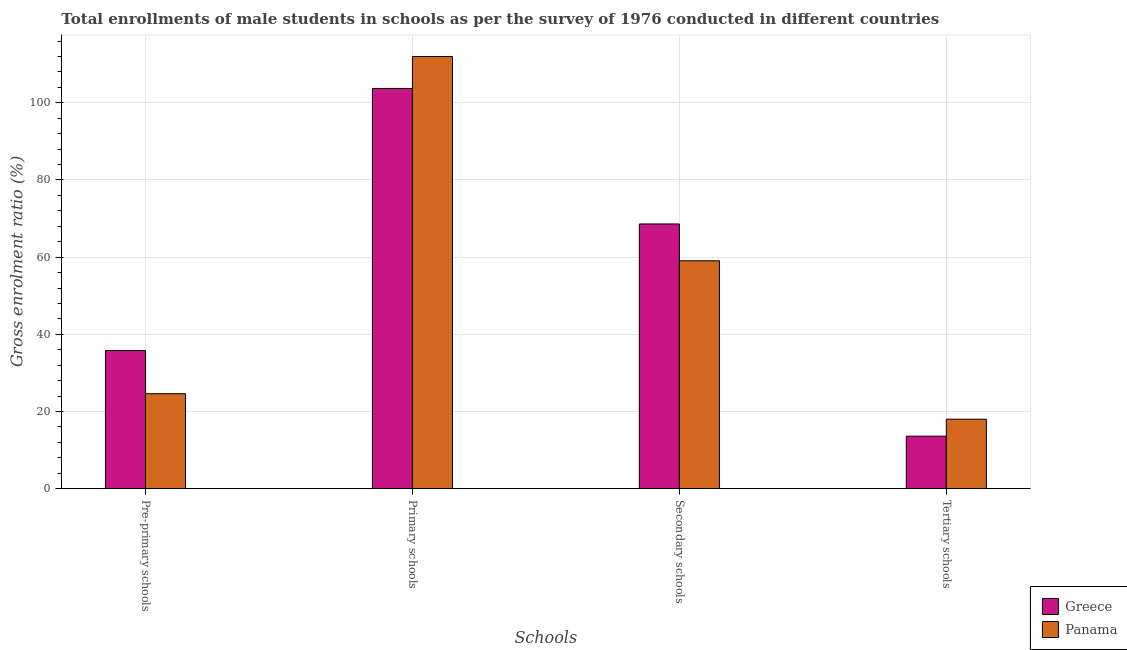Are the number of bars per tick equal to the number of legend labels?
Provide a short and direct response. Yes. How many bars are there on the 4th tick from the left?
Make the answer very short. 2. How many bars are there on the 1st tick from the right?
Your response must be concise. 2. What is the label of the 3rd group of bars from the left?
Ensure brevity in your answer.  Secondary schools. What is the gross enrolment ratio(male) in tertiary schools in Greece?
Give a very brief answer. 13.6. Across all countries, what is the maximum gross enrolment ratio(male) in primary schools?
Your answer should be compact. 112. Across all countries, what is the minimum gross enrolment ratio(male) in pre-primary schools?
Provide a succinct answer. 24.62. In which country was the gross enrolment ratio(male) in pre-primary schools maximum?
Ensure brevity in your answer.  Greece. In which country was the gross enrolment ratio(male) in pre-primary schools minimum?
Your response must be concise. Panama. What is the total gross enrolment ratio(male) in primary schools in the graph?
Ensure brevity in your answer.  215.71. What is the difference between the gross enrolment ratio(male) in pre-primary schools in Panama and that in Greece?
Keep it short and to the point. -11.18. What is the difference between the gross enrolment ratio(male) in tertiary schools in Greece and the gross enrolment ratio(male) in secondary schools in Panama?
Your answer should be compact. -45.45. What is the average gross enrolment ratio(male) in secondary schools per country?
Provide a succinct answer. 63.82. What is the difference between the gross enrolment ratio(male) in tertiary schools and gross enrolment ratio(male) in primary schools in Greece?
Provide a short and direct response. -90.11. What is the ratio of the gross enrolment ratio(male) in secondary schools in Greece to that in Panama?
Your response must be concise. 1.16. Is the difference between the gross enrolment ratio(male) in tertiary schools in Greece and Panama greater than the difference between the gross enrolment ratio(male) in secondary schools in Greece and Panama?
Keep it short and to the point. No. What is the difference between the highest and the second highest gross enrolment ratio(male) in secondary schools?
Your answer should be compact. 9.55. What is the difference between the highest and the lowest gross enrolment ratio(male) in pre-primary schools?
Your response must be concise. 11.18. In how many countries, is the gross enrolment ratio(male) in secondary schools greater than the average gross enrolment ratio(male) in secondary schools taken over all countries?
Ensure brevity in your answer.  1. Is the sum of the gross enrolment ratio(male) in pre-primary schools in Greece and Panama greater than the maximum gross enrolment ratio(male) in tertiary schools across all countries?
Your response must be concise. Yes. Is it the case that in every country, the sum of the gross enrolment ratio(male) in pre-primary schools and gross enrolment ratio(male) in tertiary schools is greater than the sum of gross enrolment ratio(male) in primary schools and gross enrolment ratio(male) in secondary schools?
Your answer should be very brief. No. What does the 2nd bar from the left in Primary schools represents?
Give a very brief answer. Panama. What does the 2nd bar from the right in Primary schools represents?
Keep it short and to the point. Greece. Is it the case that in every country, the sum of the gross enrolment ratio(male) in pre-primary schools and gross enrolment ratio(male) in primary schools is greater than the gross enrolment ratio(male) in secondary schools?
Make the answer very short. Yes. Are all the bars in the graph horizontal?
Keep it short and to the point. No. How many countries are there in the graph?
Make the answer very short. 2. What is the difference between two consecutive major ticks on the Y-axis?
Keep it short and to the point. 20. Are the values on the major ticks of Y-axis written in scientific E-notation?
Make the answer very short. No. Does the graph contain any zero values?
Offer a terse response. No. Where does the legend appear in the graph?
Ensure brevity in your answer.  Bottom right. What is the title of the graph?
Provide a short and direct response. Total enrollments of male students in schools as per the survey of 1976 conducted in different countries. Does "Tajikistan" appear as one of the legend labels in the graph?
Your answer should be very brief. No. What is the label or title of the X-axis?
Your answer should be very brief. Schools. What is the Gross enrolment ratio (%) of Greece in Pre-primary schools?
Provide a short and direct response. 35.79. What is the Gross enrolment ratio (%) in Panama in Pre-primary schools?
Offer a terse response. 24.62. What is the Gross enrolment ratio (%) of Greece in Primary schools?
Your answer should be very brief. 103.71. What is the Gross enrolment ratio (%) of Panama in Primary schools?
Your answer should be very brief. 112. What is the Gross enrolment ratio (%) of Greece in Secondary schools?
Offer a very short reply. 68.6. What is the Gross enrolment ratio (%) in Panama in Secondary schools?
Give a very brief answer. 59.05. What is the Gross enrolment ratio (%) in Greece in Tertiary schools?
Provide a short and direct response. 13.6. What is the Gross enrolment ratio (%) in Panama in Tertiary schools?
Keep it short and to the point. 18.01. Across all Schools, what is the maximum Gross enrolment ratio (%) of Greece?
Offer a terse response. 103.71. Across all Schools, what is the maximum Gross enrolment ratio (%) of Panama?
Provide a succinct answer. 112. Across all Schools, what is the minimum Gross enrolment ratio (%) of Greece?
Offer a terse response. 13.6. Across all Schools, what is the minimum Gross enrolment ratio (%) of Panama?
Your answer should be very brief. 18.01. What is the total Gross enrolment ratio (%) of Greece in the graph?
Your answer should be very brief. 221.7. What is the total Gross enrolment ratio (%) in Panama in the graph?
Provide a short and direct response. 213.67. What is the difference between the Gross enrolment ratio (%) of Greece in Pre-primary schools and that in Primary schools?
Ensure brevity in your answer.  -67.92. What is the difference between the Gross enrolment ratio (%) of Panama in Pre-primary schools and that in Primary schools?
Keep it short and to the point. -87.38. What is the difference between the Gross enrolment ratio (%) in Greece in Pre-primary schools and that in Secondary schools?
Your answer should be very brief. -32.81. What is the difference between the Gross enrolment ratio (%) of Panama in Pre-primary schools and that in Secondary schools?
Ensure brevity in your answer.  -34.44. What is the difference between the Gross enrolment ratio (%) of Greece in Pre-primary schools and that in Tertiary schools?
Make the answer very short. 22.19. What is the difference between the Gross enrolment ratio (%) in Panama in Pre-primary schools and that in Tertiary schools?
Offer a very short reply. 6.61. What is the difference between the Gross enrolment ratio (%) in Greece in Primary schools and that in Secondary schools?
Give a very brief answer. 35.12. What is the difference between the Gross enrolment ratio (%) of Panama in Primary schools and that in Secondary schools?
Ensure brevity in your answer.  52.95. What is the difference between the Gross enrolment ratio (%) of Greece in Primary schools and that in Tertiary schools?
Ensure brevity in your answer.  90.11. What is the difference between the Gross enrolment ratio (%) of Panama in Primary schools and that in Tertiary schools?
Provide a short and direct response. 93.99. What is the difference between the Gross enrolment ratio (%) in Greece in Secondary schools and that in Tertiary schools?
Give a very brief answer. 55. What is the difference between the Gross enrolment ratio (%) in Panama in Secondary schools and that in Tertiary schools?
Ensure brevity in your answer.  41.04. What is the difference between the Gross enrolment ratio (%) in Greece in Pre-primary schools and the Gross enrolment ratio (%) in Panama in Primary schools?
Offer a terse response. -76.21. What is the difference between the Gross enrolment ratio (%) of Greece in Pre-primary schools and the Gross enrolment ratio (%) of Panama in Secondary schools?
Make the answer very short. -23.26. What is the difference between the Gross enrolment ratio (%) in Greece in Pre-primary schools and the Gross enrolment ratio (%) in Panama in Tertiary schools?
Give a very brief answer. 17.78. What is the difference between the Gross enrolment ratio (%) in Greece in Primary schools and the Gross enrolment ratio (%) in Panama in Secondary schools?
Your answer should be very brief. 44.66. What is the difference between the Gross enrolment ratio (%) of Greece in Primary schools and the Gross enrolment ratio (%) of Panama in Tertiary schools?
Offer a terse response. 85.7. What is the difference between the Gross enrolment ratio (%) of Greece in Secondary schools and the Gross enrolment ratio (%) of Panama in Tertiary schools?
Your answer should be very brief. 50.59. What is the average Gross enrolment ratio (%) of Greece per Schools?
Keep it short and to the point. 55.43. What is the average Gross enrolment ratio (%) of Panama per Schools?
Offer a terse response. 53.42. What is the difference between the Gross enrolment ratio (%) in Greece and Gross enrolment ratio (%) in Panama in Pre-primary schools?
Keep it short and to the point. 11.18. What is the difference between the Gross enrolment ratio (%) of Greece and Gross enrolment ratio (%) of Panama in Primary schools?
Offer a terse response. -8.29. What is the difference between the Gross enrolment ratio (%) in Greece and Gross enrolment ratio (%) in Panama in Secondary schools?
Ensure brevity in your answer.  9.55. What is the difference between the Gross enrolment ratio (%) of Greece and Gross enrolment ratio (%) of Panama in Tertiary schools?
Provide a short and direct response. -4.41. What is the ratio of the Gross enrolment ratio (%) in Greece in Pre-primary schools to that in Primary schools?
Offer a terse response. 0.35. What is the ratio of the Gross enrolment ratio (%) in Panama in Pre-primary schools to that in Primary schools?
Provide a short and direct response. 0.22. What is the ratio of the Gross enrolment ratio (%) in Greece in Pre-primary schools to that in Secondary schools?
Provide a succinct answer. 0.52. What is the ratio of the Gross enrolment ratio (%) of Panama in Pre-primary schools to that in Secondary schools?
Keep it short and to the point. 0.42. What is the ratio of the Gross enrolment ratio (%) of Greece in Pre-primary schools to that in Tertiary schools?
Offer a very short reply. 2.63. What is the ratio of the Gross enrolment ratio (%) of Panama in Pre-primary schools to that in Tertiary schools?
Your response must be concise. 1.37. What is the ratio of the Gross enrolment ratio (%) in Greece in Primary schools to that in Secondary schools?
Ensure brevity in your answer.  1.51. What is the ratio of the Gross enrolment ratio (%) in Panama in Primary schools to that in Secondary schools?
Offer a very short reply. 1.9. What is the ratio of the Gross enrolment ratio (%) in Greece in Primary schools to that in Tertiary schools?
Give a very brief answer. 7.62. What is the ratio of the Gross enrolment ratio (%) of Panama in Primary schools to that in Tertiary schools?
Provide a succinct answer. 6.22. What is the ratio of the Gross enrolment ratio (%) of Greece in Secondary schools to that in Tertiary schools?
Keep it short and to the point. 5.04. What is the ratio of the Gross enrolment ratio (%) in Panama in Secondary schools to that in Tertiary schools?
Make the answer very short. 3.28. What is the difference between the highest and the second highest Gross enrolment ratio (%) of Greece?
Provide a succinct answer. 35.12. What is the difference between the highest and the second highest Gross enrolment ratio (%) in Panama?
Provide a succinct answer. 52.95. What is the difference between the highest and the lowest Gross enrolment ratio (%) of Greece?
Offer a very short reply. 90.11. What is the difference between the highest and the lowest Gross enrolment ratio (%) in Panama?
Offer a very short reply. 93.99. 